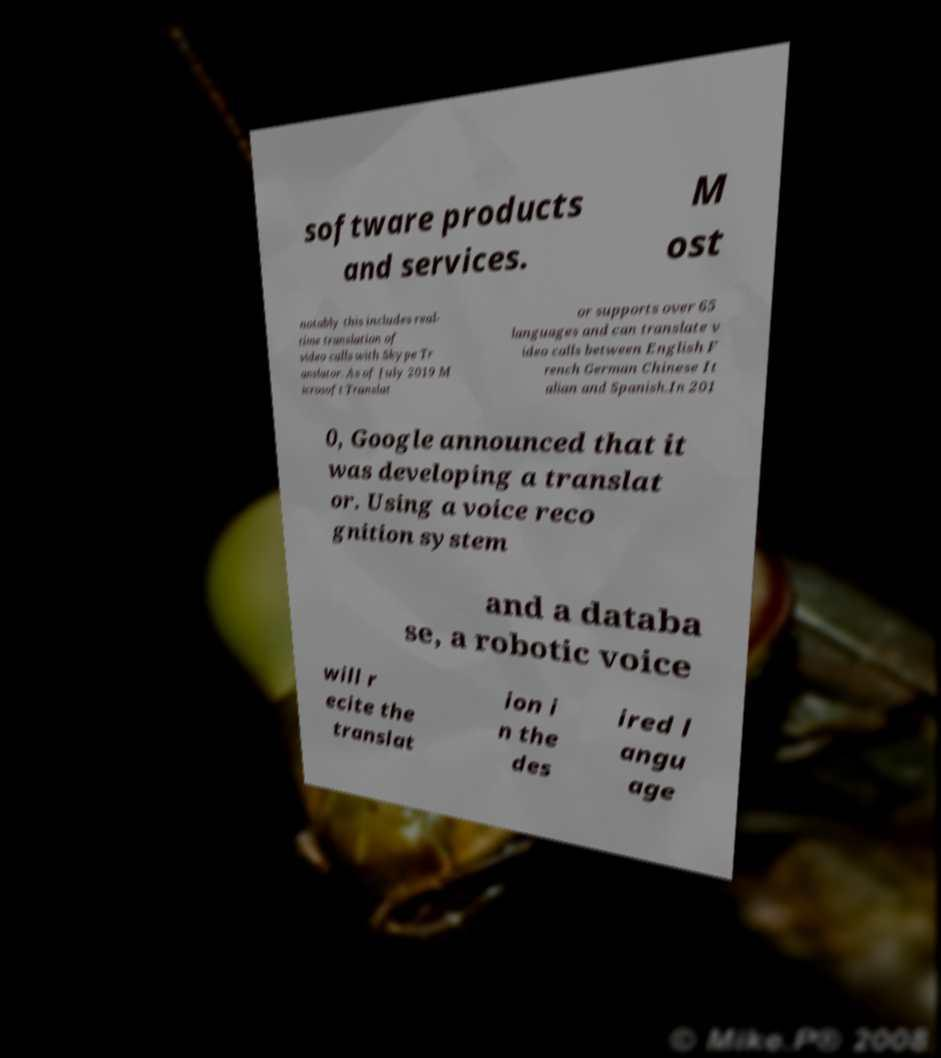For documentation purposes, I need the text within this image transcribed. Could you provide that? software products and services. M ost notably this includes real- time translation of video calls with Skype Tr anslator. As of July 2019 M icrosoft Translat or supports over 65 languages and can translate v ideo calls between English F rench German Chinese It alian and Spanish.In 201 0, Google announced that it was developing a translat or. Using a voice reco gnition system and a databa se, a robotic voice will r ecite the translat ion i n the des ired l angu age 